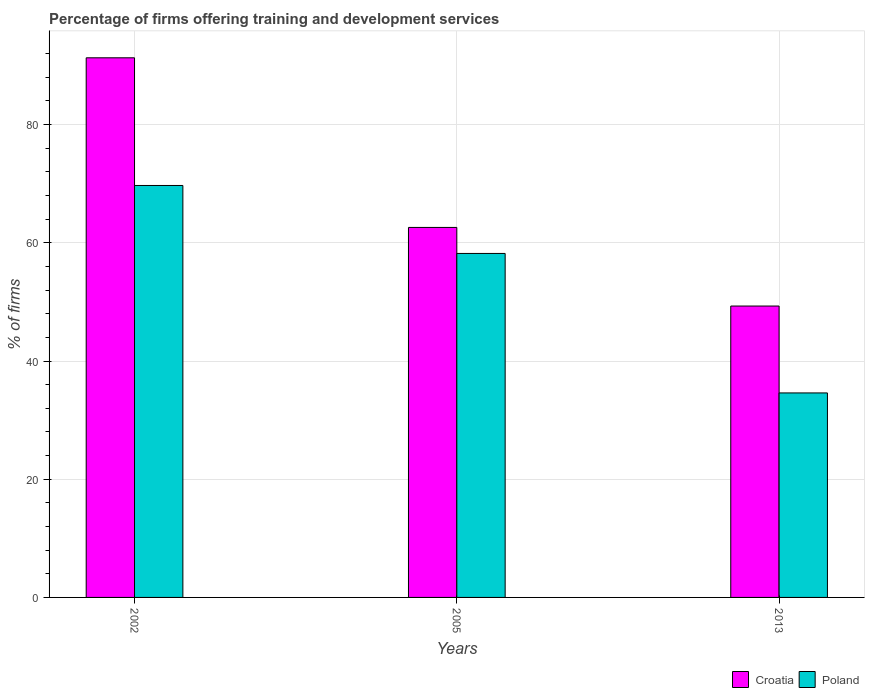How many different coloured bars are there?
Provide a succinct answer. 2. Are the number of bars per tick equal to the number of legend labels?
Give a very brief answer. Yes. Are the number of bars on each tick of the X-axis equal?
Your answer should be compact. Yes. How many bars are there on the 1st tick from the right?
Your answer should be compact. 2. What is the label of the 2nd group of bars from the left?
Provide a succinct answer. 2005. In how many cases, is the number of bars for a given year not equal to the number of legend labels?
Offer a terse response. 0. What is the percentage of firms offering training and development in Croatia in 2002?
Offer a very short reply. 91.3. Across all years, what is the maximum percentage of firms offering training and development in Croatia?
Provide a succinct answer. 91.3. Across all years, what is the minimum percentage of firms offering training and development in Poland?
Your answer should be very brief. 34.6. In which year was the percentage of firms offering training and development in Croatia maximum?
Make the answer very short. 2002. What is the total percentage of firms offering training and development in Poland in the graph?
Offer a very short reply. 162.5. What is the difference between the percentage of firms offering training and development in Croatia in 2002 and that in 2005?
Your answer should be very brief. 28.7. What is the difference between the percentage of firms offering training and development in Croatia in 2005 and the percentage of firms offering training and development in Poland in 2002?
Your response must be concise. -7.1. What is the average percentage of firms offering training and development in Croatia per year?
Provide a short and direct response. 67.73. In the year 2005, what is the difference between the percentage of firms offering training and development in Poland and percentage of firms offering training and development in Croatia?
Your answer should be compact. -4.4. In how many years, is the percentage of firms offering training and development in Croatia greater than 16 %?
Ensure brevity in your answer.  3. What is the ratio of the percentage of firms offering training and development in Poland in 2002 to that in 2005?
Your answer should be compact. 1.2. What is the difference between the highest and the second highest percentage of firms offering training and development in Croatia?
Make the answer very short. 28.7. What does the 2nd bar from the right in 2002 represents?
Give a very brief answer. Croatia. How many bars are there?
Keep it short and to the point. 6. What is the difference between two consecutive major ticks on the Y-axis?
Provide a succinct answer. 20. How many legend labels are there?
Your answer should be very brief. 2. How are the legend labels stacked?
Keep it short and to the point. Horizontal. What is the title of the graph?
Provide a succinct answer. Percentage of firms offering training and development services. What is the label or title of the Y-axis?
Your response must be concise. % of firms. What is the % of firms in Croatia in 2002?
Provide a short and direct response. 91.3. What is the % of firms in Poland in 2002?
Your answer should be compact. 69.7. What is the % of firms in Croatia in 2005?
Keep it short and to the point. 62.6. What is the % of firms of Poland in 2005?
Make the answer very short. 58.2. What is the % of firms in Croatia in 2013?
Offer a terse response. 49.3. What is the % of firms in Poland in 2013?
Ensure brevity in your answer.  34.6. Across all years, what is the maximum % of firms of Croatia?
Your answer should be very brief. 91.3. Across all years, what is the maximum % of firms in Poland?
Keep it short and to the point. 69.7. Across all years, what is the minimum % of firms of Croatia?
Ensure brevity in your answer.  49.3. Across all years, what is the minimum % of firms of Poland?
Give a very brief answer. 34.6. What is the total % of firms in Croatia in the graph?
Your response must be concise. 203.2. What is the total % of firms in Poland in the graph?
Your answer should be very brief. 162.5. What is the difference between the % of firms of Croatia in 2002 and that in 2005?
Your answer should be compact. 28.7. What is the difference between the % of firms of Poland in 2002 and that in 2005?
Provide a succinct answer. 11.5. What is the difference between the % of firms in Croatia in 2002 and that in 2013?
Provide a short and direct response. 42. What is the difference between the % of firms of Poland in 2002 and that in 2013?
Provide a succinct answer. 35.1. What is the difference between the % of firms in Poland in 2005 and that in 2013?
Your answer should be compact. 23.6. What is the difference between the % of firms in Croatia in 2002 and the % of firms in Poland in 2005?
Your answer should be very brief. 33.1. What is the difference between the % of firms in Croatia in 2002 and the % of firms in Poland in 2013?
Ensure brevity in your answer.  56.7. What is the average % of firms in Croatia per year?
Make the answer very short. 67.73. What is the average % of firms of Poland per year?
Offer a very short reply. 54.17. In the year 2002, what is the difference between the % of firms of Croatia and % of firms of Poland?
Your answer should be compact. 21.6. In the year 2013, what is the difference between the % of firms in Croatia and % of firms in Poland?
Your response must be concise. 14.7. What is the ratio of the % of firms in Croatia in 2002 to that in 2005?
Make the answer very short. 1.46. What is the ratio of the % of firms of Poland in 2002 to that in 2005?
Your response must be concise. 1.2. What is the ratio of the % of firms of Croatia in 2002 to that in 2013?
Ensure brevity in your answer.  1.85. What is the ratio of the % of firms of Poland in 2002 to that in 2013?
Offer a very short reply. 2.01. What is the ratio of the % of firms in Croatia in 2005 to that in 2013?
Your answer should be compact. 1.27. What is the ratio of the % of firms of Poland in 2005 to that in 2013?
Ensure brevity in your answer.  1.68. What is the difference between the highest and the second highest % of firms in Croatia?
Ensure brevity in your answer.  28.7. What is the difference between the highest and the second highest % of firms of Poland?
Offer a very short reply. 11.5. What is the difference between the highest and the lowest % of firms of Croatia?
Make the answer very short. 42. What is the difference between the highest and the lowest % of firms in Poland?
Offer a terse response. 35.1. 